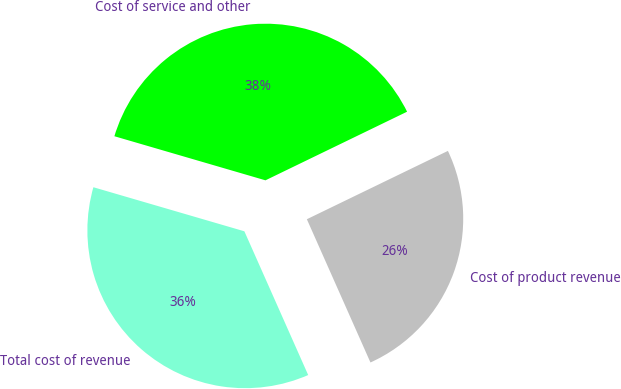Convert chart to OTSL. <chart><loc_0><loc_0><loc_500><loc_500><pie_chart><fcel>Cost of product revenue<fcel>Cost of service and other<fcel>Total cost of revenue<nl><fcel>25.53%<fcel>38.3%<fcel>36.17%<nl></chart> 